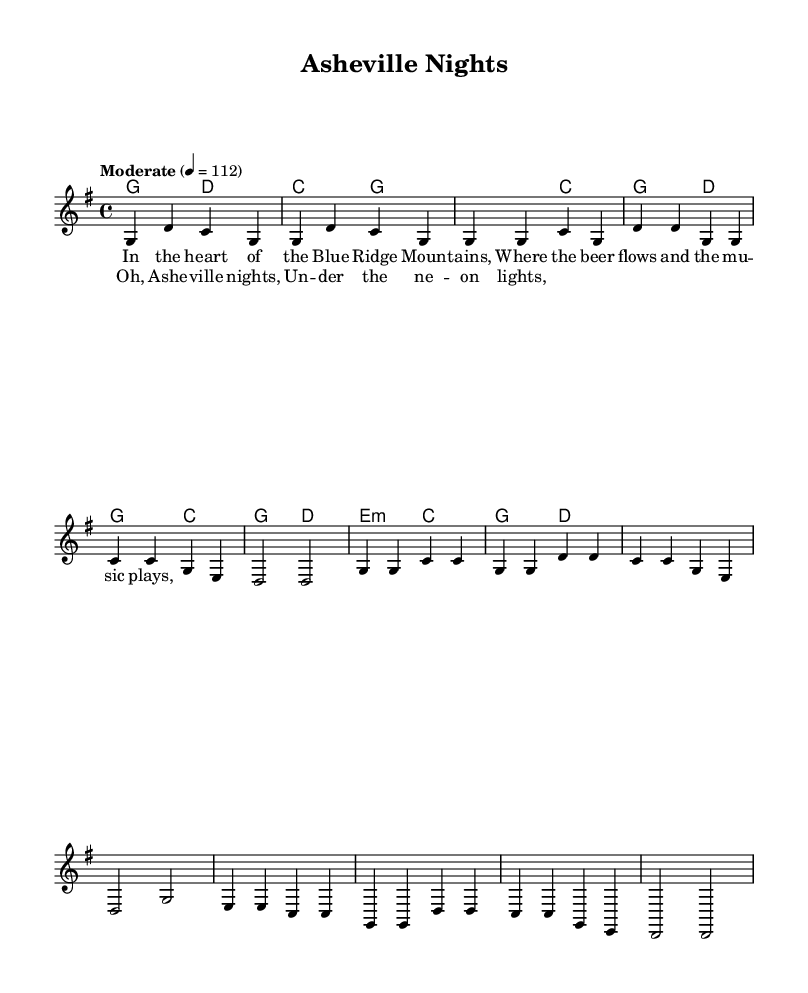What is the key signature of this music? The music is written in the key of G major, which has one sharp (F#) indicated by the key signature.
Answer: G major What is the time signature of this music? The time signature is indicated as 4/4, meaning there are four beats in each measure and the quarter note receives one beat.
Answer: 4/4 What is the tempo marking of this music? The tempo marking indicates that the piece should be played at a moderate tempo of 112 beats per minute.
Answer: Moderate 112 How many bars are there in the verse? The verse consists of 8 measures, as indicated by the sequence of notes and corresponding rests.
Answer: 8 What is the first note of the melody? The first note of the melody is G, as seen in the opening measure of the score.
Answer: G What is the last note of the chorus? The last note of the chorus is G, which appears in the closing measure of that section.
Answer: G What emotion do the lyrics evoke in this song? The lyrics describe a sense of local pride and enjoyment associated with small-town life, particularly in Asheville.
Answer: Pride 